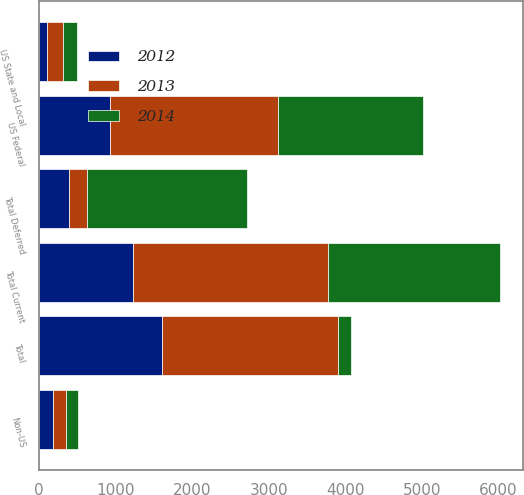Convert chart. <chart><loc_0><loc_0><loc_500><loc_500><stacked_bar_chart><ecel><fcel>US Federal<fcel>US State and Local<fcel>Non-US<fcel>Total Current<fcel>Total Deferred<fcel>Total<nl><fcel>2012<fcel>932<fcel>103<fcel>185<fcel>1220<fcel>385<fcel>1605<nl><fcel>2013<fcel>2181<fcel>205<fcel>162<fcel>2548<fcel>246<fcel>2302<nl><fcel>2014<fcel>1901<fcel>182<fcel>167<fcel>2250<fcel>2083<fcel>167<nl></chart> 